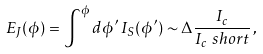Convert formula to latex. <formula><loc_0><loc_0><loc_500><loc_500>E _ { J } ( \phi ) = \int ^ { \phi } { d \phi ^ { \prime } } \, I _ { S } ( \phi ^ { \prime } ) \sim \Delta \frac { I _ { c } } { I _ { c } ^ { \ } s h o r t } \, ,</formula> 